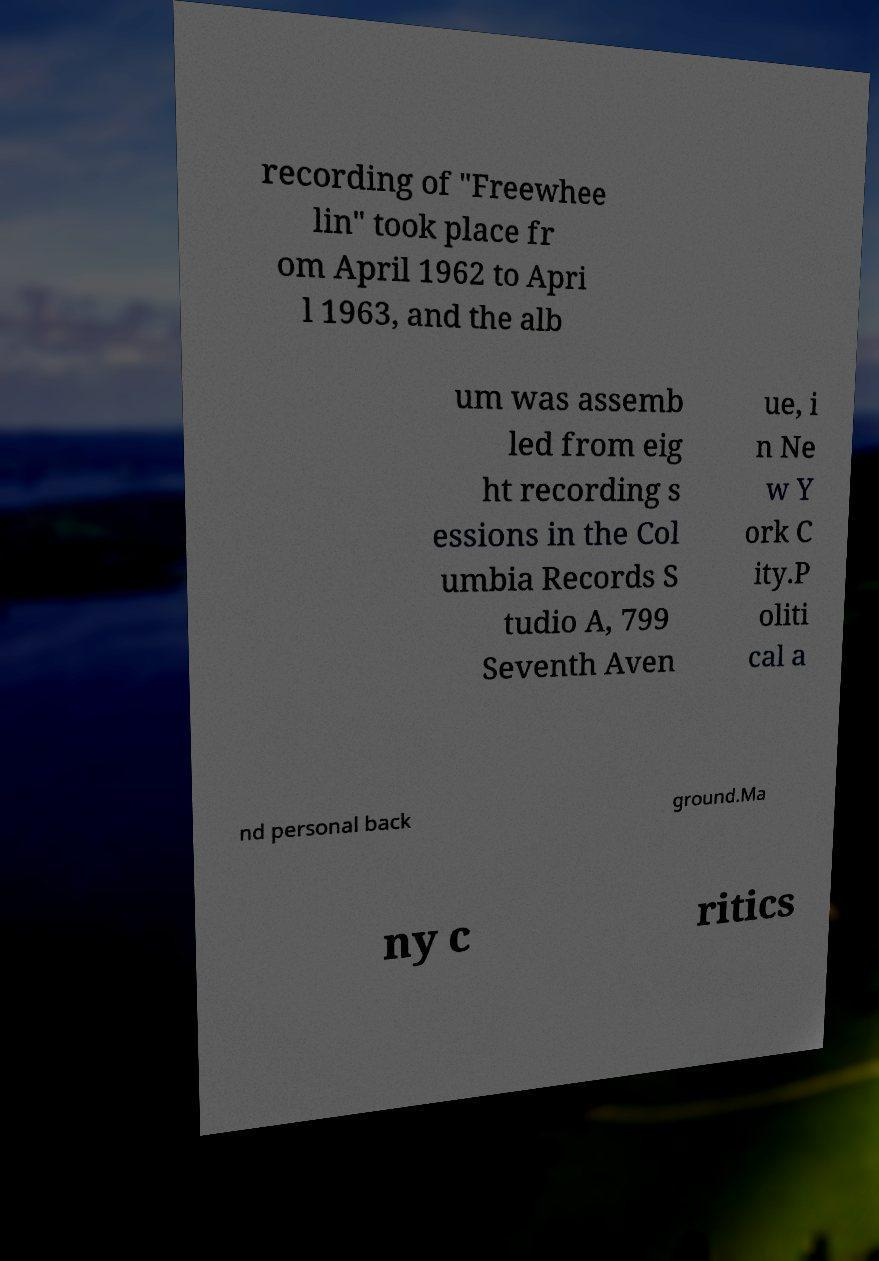I need the written content from this picture converted into text. Can you do that? recording of "Freewhee lin" took place fr om April 1962 to Apri l 1963, and the alb um was assemb led from eig ht recording s essions in the Col umbia Records S tudio A, 799 Seventh Aven ue, i n Ne w Y ork C ity.P oliti cal a nd personal back ground.Ma ny c ritics 